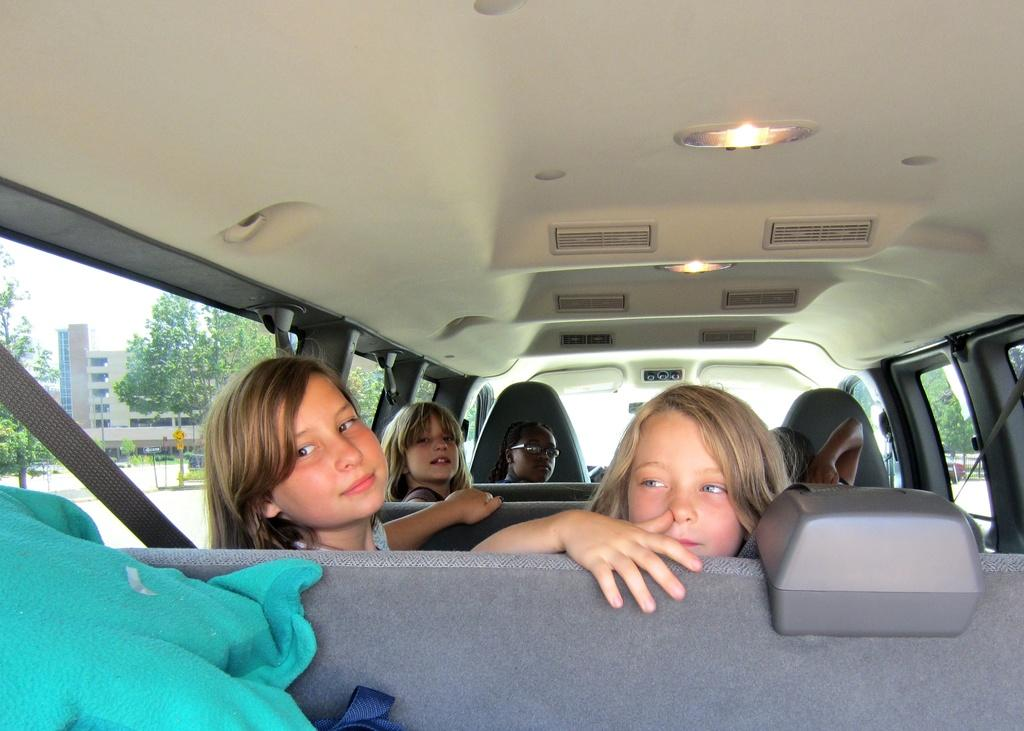How many people are in the car in the image? There are five people in the car. How are the people seated in the car? Two people are sitting in each row. What can be seen to the right of the car in the image? There is a tree visible to the right of the car. What is located behind the tree in the image? There is a building behind the tree. Reasoning: Let's think step by step by step in order to produce the conversation. We start by identifying the main subject in the image, which is the car with people inside. Then, we expand the conversation to include details about the seating arrangement of the people and the objects visible outside the car. Each question is designed to elicit a specific detail about the image that is known from the provided facts. Absurd Question/Answer: What type of toy can be seen in the car with the people? There is no toy visible in the car with the people; the image only shows the car, people, tree, and building. What type of animal can be seen at the zoo in the image? There is no zoo or animals present in the image; it only shows a car, people, tree, and building. 